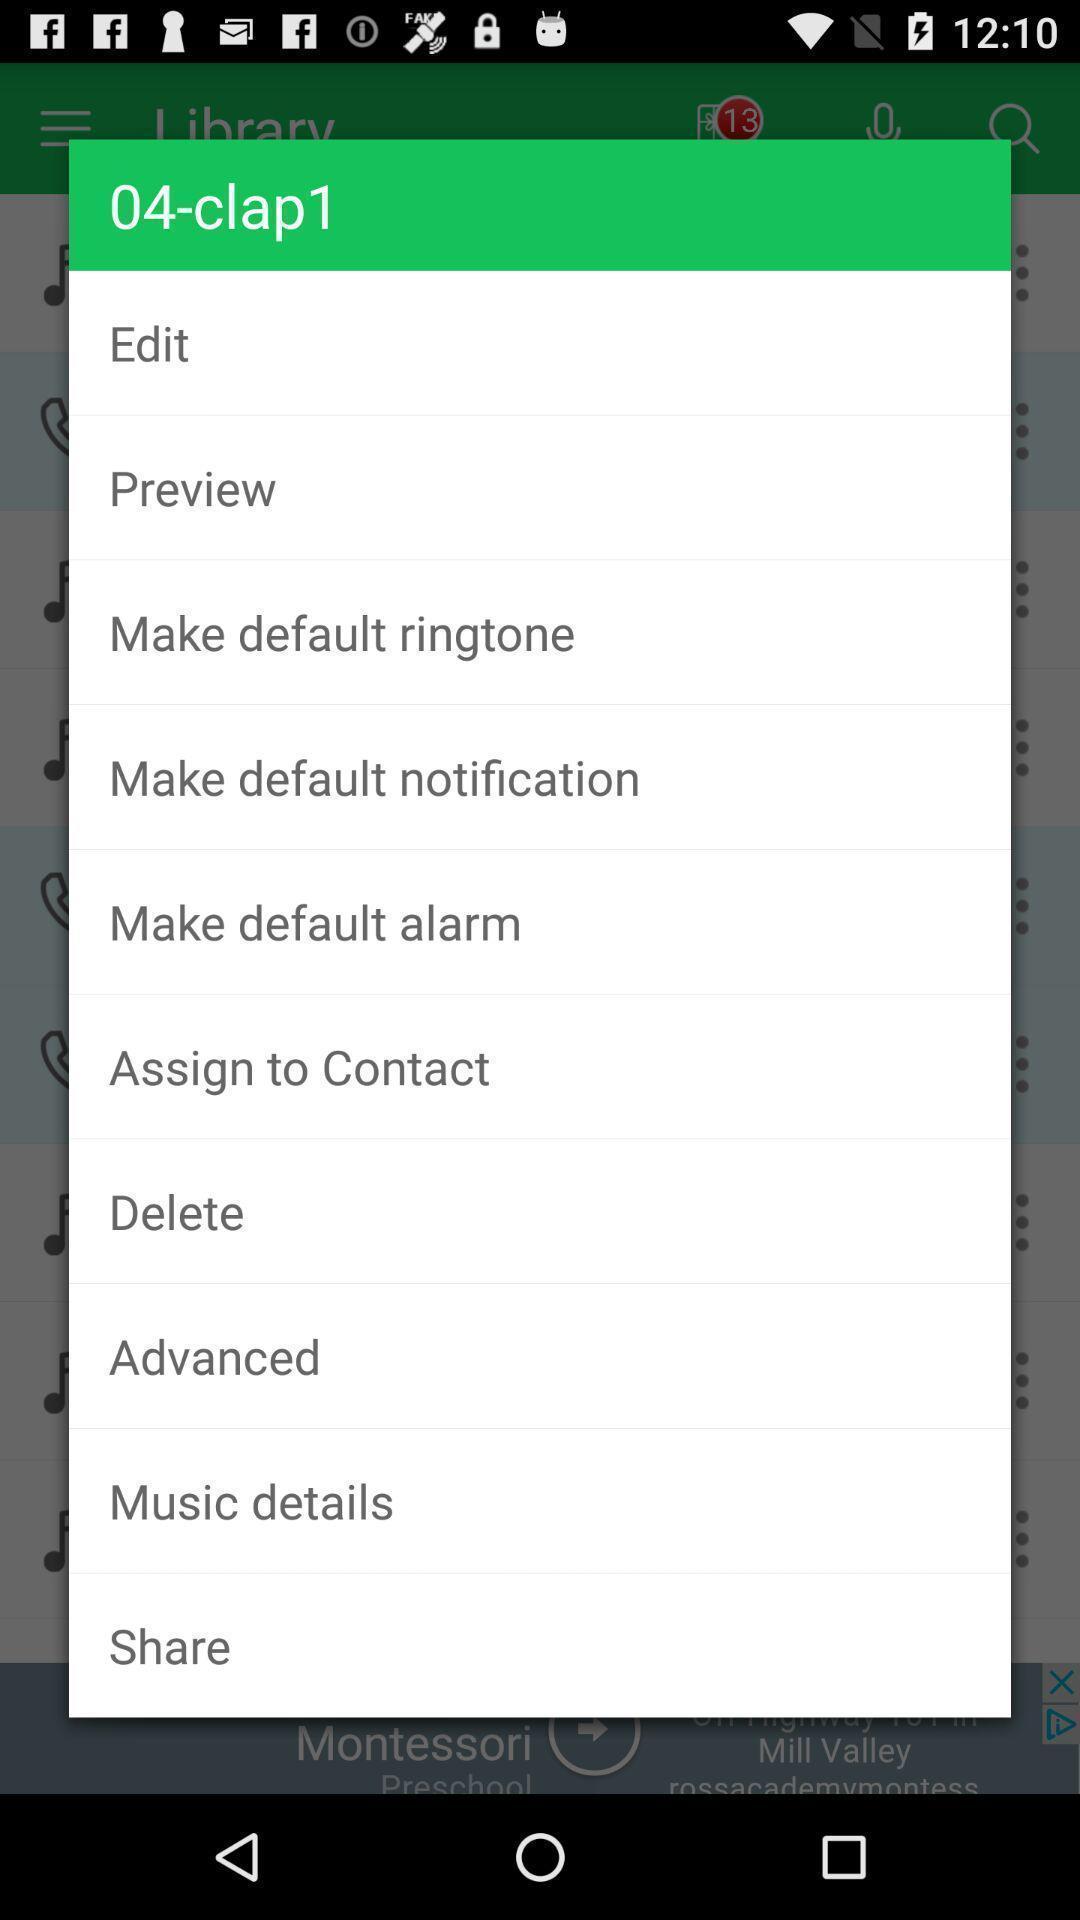Describe the key features of this screenshot. Pop-up showing multiple options. 